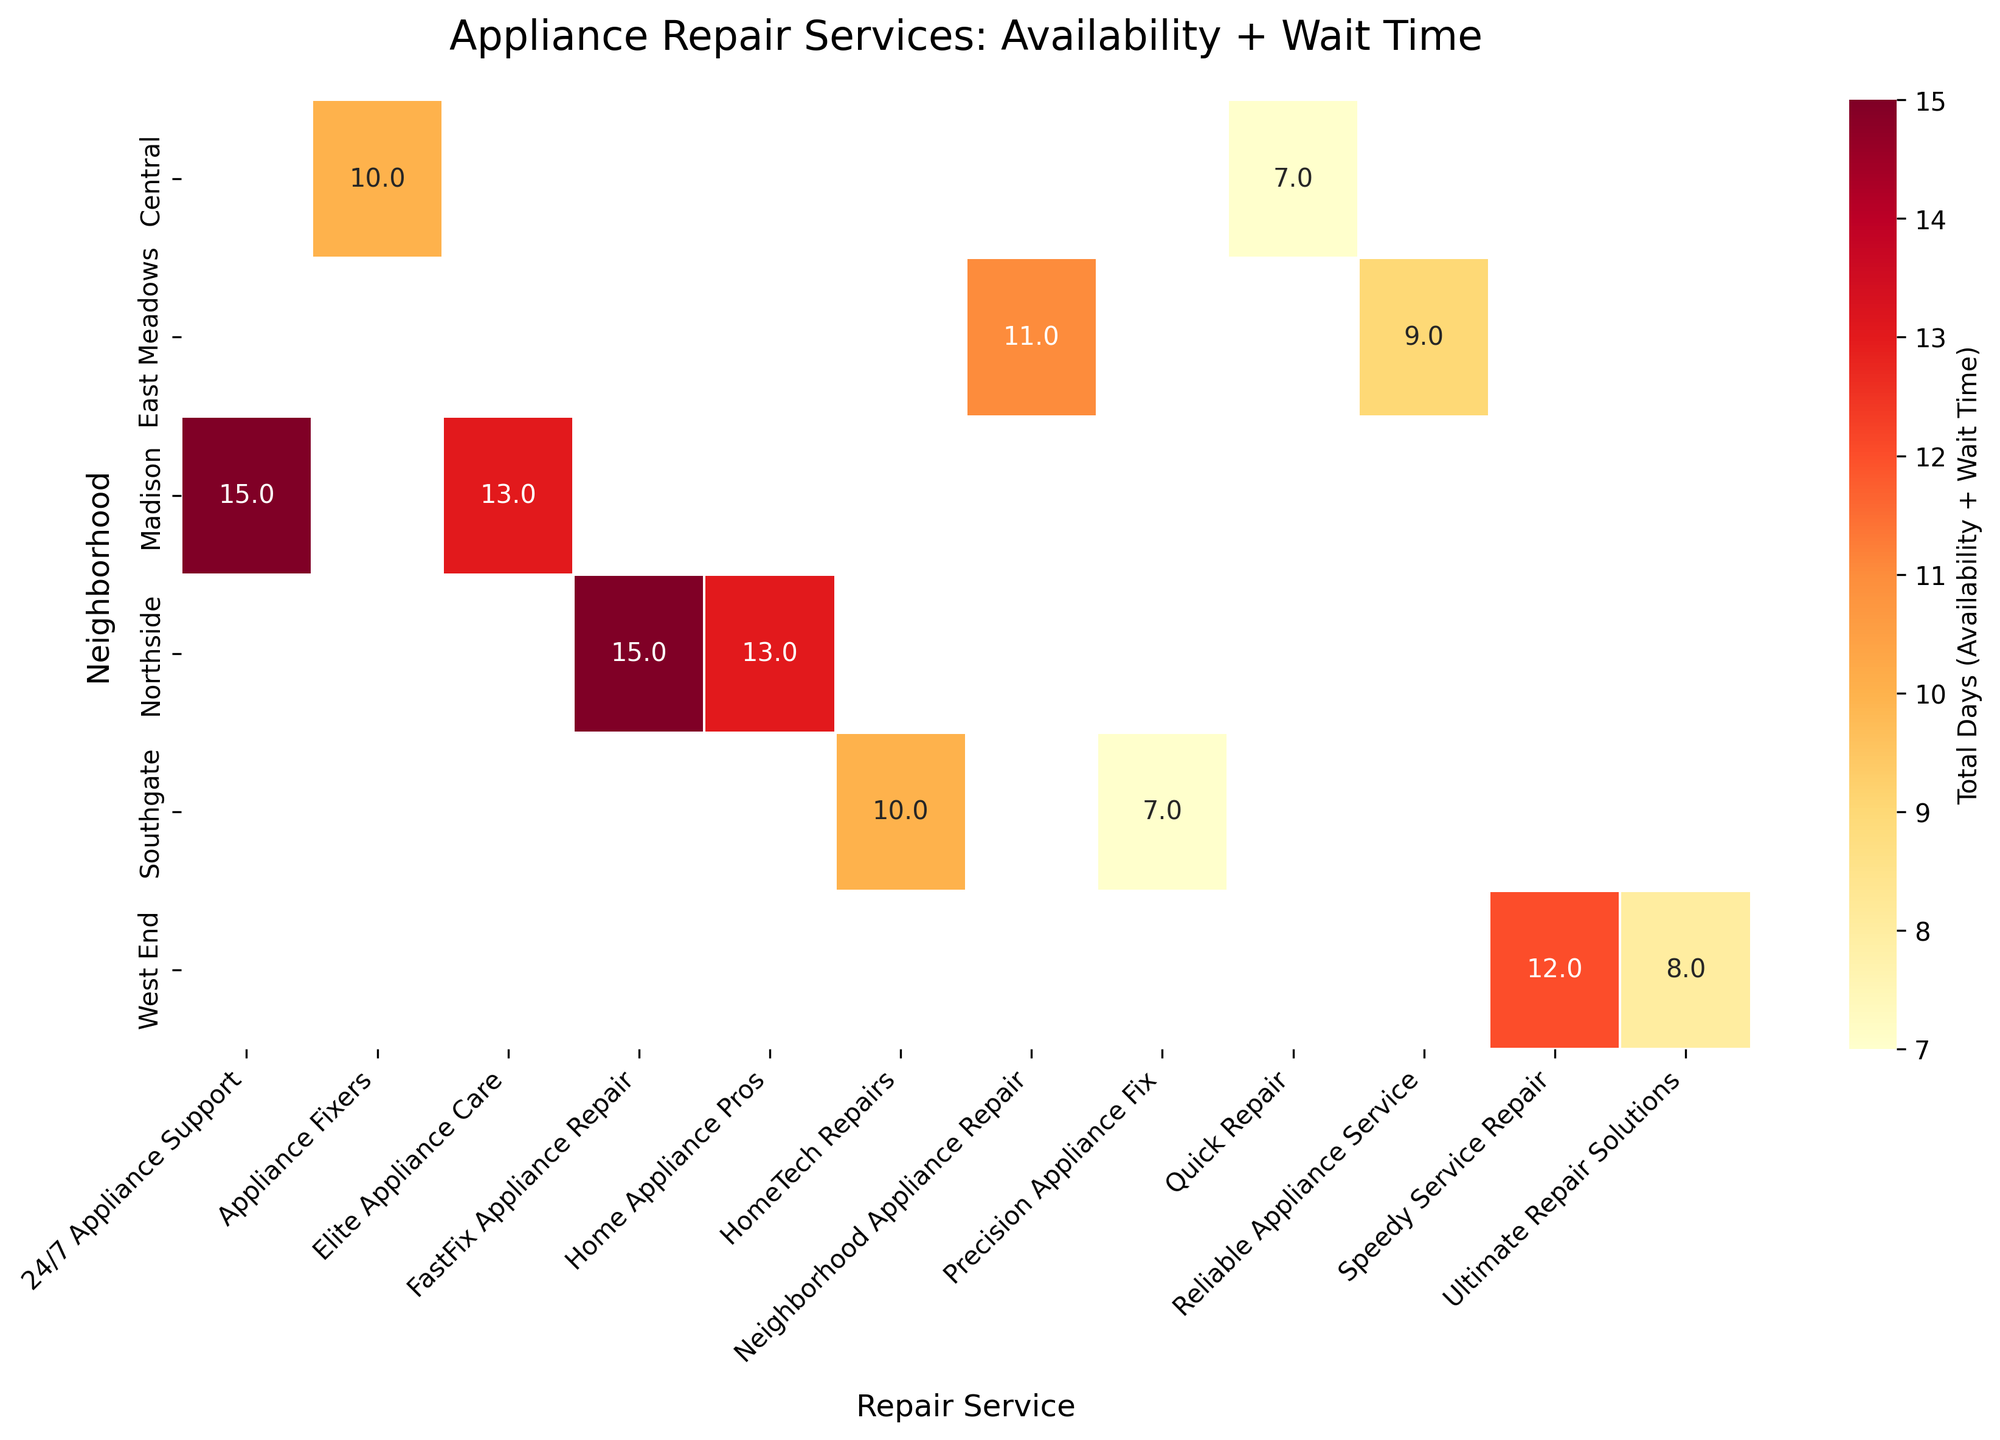What is the title of the heatmap? The title of the heatmap can be found at the top of the figure, typically in a larger and bolder font compared to other text elements.
Answer: Appliance Repair Services: Availability + Wait Time Which repair service in the Northside neighborhood has the highest total days? To find the highest total days in Northside, look at the entries in the Northside row and identify the maximum value.
Answer: FastFix Appliance Repair How many neighborhoods are included in the heatmap? The number of neighborhoods can be determined by counting the unique labels on the y-axis.
Answer: 6 What is the total combined days for "Quick Repair" in the Central neighborhood? Locate the intersection of the Quick Repair column and the Central row to find this value directly from the heatmap.
Answer: 7 Which repair service in Southgate has the shortest total days? Compare the values for both repair services in the Southgate row to see which is smaller.
Answer: Precision Appliance Fix How does the total days for Elite Appliance Care in Madison compare to 24/7 Appliance Support in the same neighborhood? Find the values for both repair services in Madison and compare them. Elite Appliance Care has 13, while 24/7 Appliance Support has 15, so Elite Appliance Care has fewer days.
Answer: Elite Appliance Care has fewer days What is the difference in total days between "Ultimate Repair Solutions" in West End and "Reliable Appliance Service" in East Meadows? Locate the values for both services and subtract the smaller from the larger. Ultimate Repair Solutions has 8, and Reliable Appliance Service has 9, so the difference is 1 day.
Answer: 1 Which neighborhood has the highest average total days across all repair services? Find the average total days in each neighborhood by summing the values in each row and dividing by the number of services per neighborhood. Compare these averages to determine the highest.
Answer: Madison What is the combined total days for all repair services in the Central neighborhood? Sum all the values in the Central row. Appliance Fixers has 10, and Quick Repair has 7, so the combined total is 10 + 7 = 17 days.
Answer: 17 Which repair service has the smallest range of total days across all neighborhoods? Determine the range (difference between highest and lowest values) for each service by examining the columns and comparing the ranges. Precision Appliance Fix ranges from 6 to 8 days, while others have wider ranges.
Answer: Precision Appliance Fix 